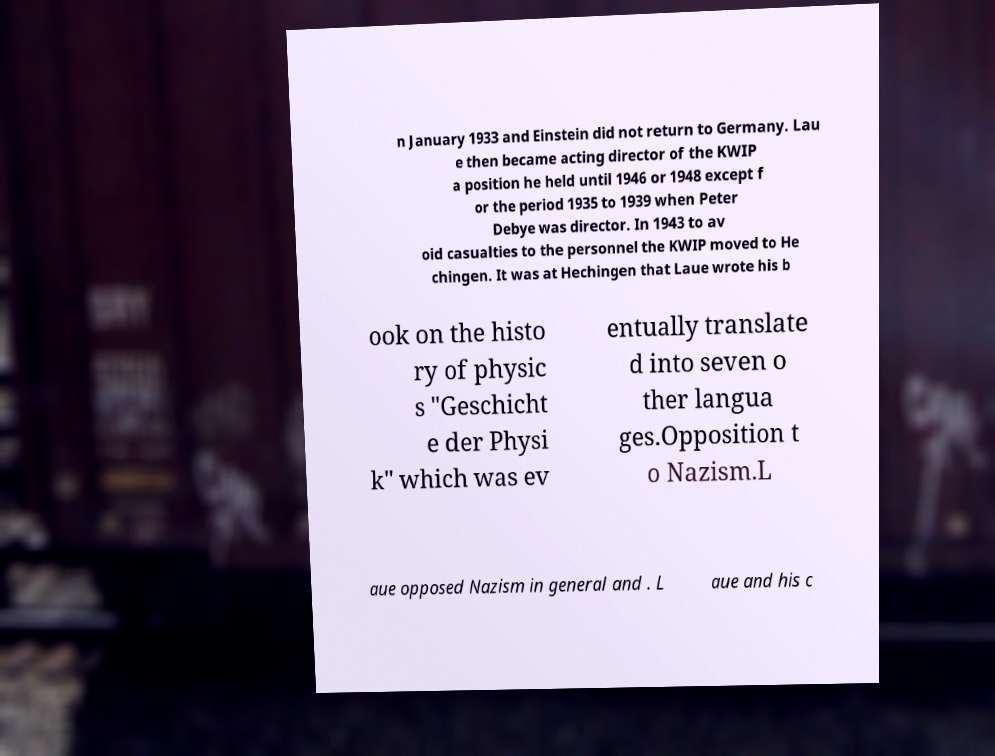Could you extract and type out the text from this image? n January 1933 and Einstein did not return to Germany. Lau e then became acting director of the KWIP a position he held until 1946 or 1948 except f or the period 1935 to 1939 when Peter Debye was director. In 1943 to av oid casualties to the personnel the KWIP moved to He chingen. It was at Hechingen that Laue wrote his b ook on the histo ry of physic s "Geschicht e der Physi k" which was ev entually translate d into seven o ther langua ges.Opposition t o Nazism.L aue opposed Nazism in general and . L aue and his c 